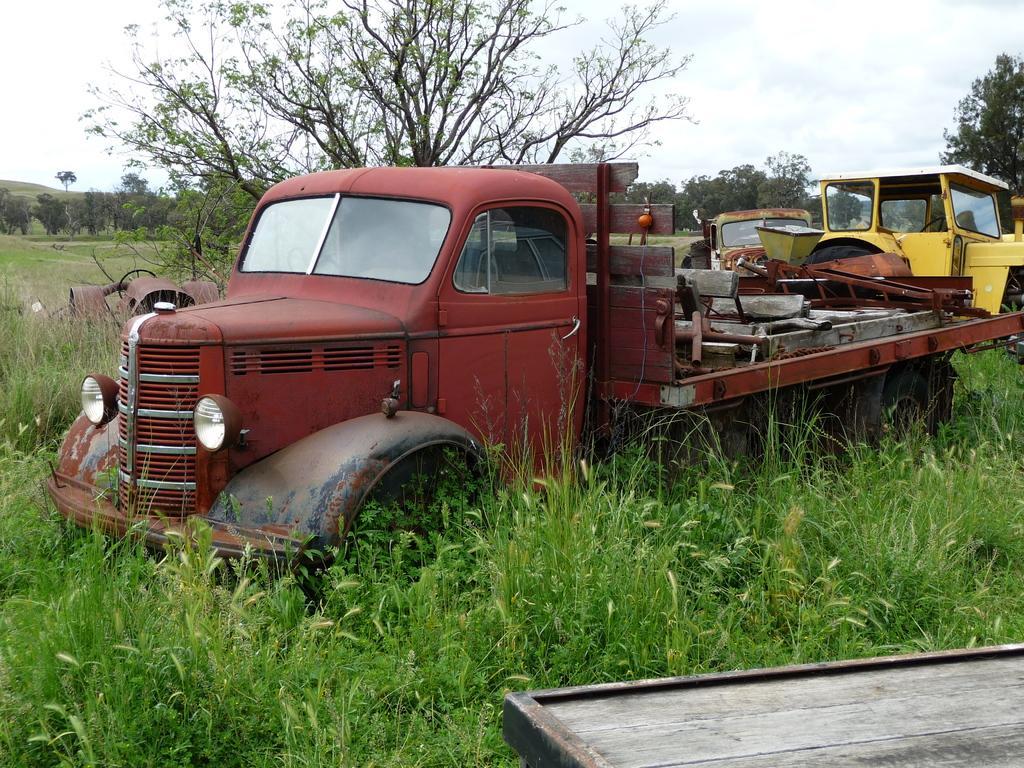In one or two sentences, can you explain what this image depicts? There are scrapped vehicles kept in a land and there are a lot of plants and trees around the vehicles. 